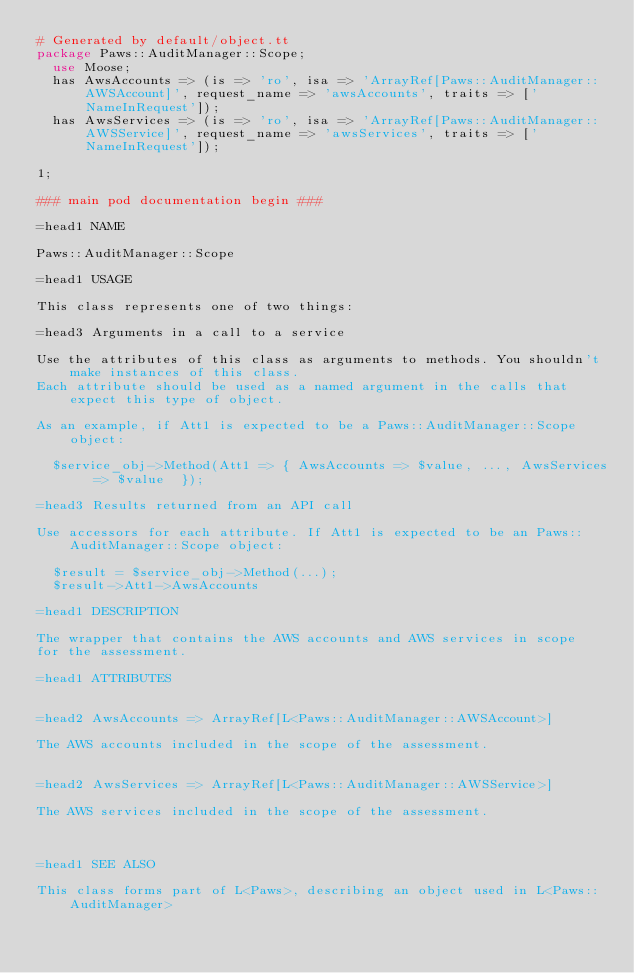<code> <loc_0><loc_0><loc_500><loc_500><_Perl_># Generated by default/object.tt
package Paws::AuditManager::Scope;
  use Moose;
  has AwsAccounts => (is => 'ro', isa => 'ArrayRef[Paws::AuditManager::AWSAccount]', request_name => 'awsAccounts', traits => ['NameInRequest']);
  has AwsServices => (is => 'ro', isa => 'ArrayRef[Paws::AuditManager::AWSService]', request_name => 'awsServices', traits => ['NameInRequest']);

1;

### main pod documentation begin ###

=head1 NAME

Paws::AuditManager::Scope

=head1 USAGE

This class represents one of two things:

=head3 Arguments in a call to a service

Use the attributes of this class as arguments to methods. You shouldn't make instances of this class. 
Each attribute should be used as a named argument in the calls that expect this type of object.

As an example, if Att1 is expected to be a Paws::AuditManager::Scope object:

  $service_obj->Method(Att1 => { AwsAccounts => $value, ..., AwsServices => $value  });

=head3 Results returned from an API call

Use accessors for each attribute. If Att1 is expected to be an Paws::AuditManager::Scope object:

  $result = $service_obj->Method(...);
  $result->Att1->AwsAccounts

=head1 DESCRIPTION

The wrapper that contains the AWS accounts and AWS services in scope
for the assessment.

=head1 ATTRIBUTES


=head2 AwsAccounts => ArrayRef[L<Paws::AuditManager::AWSAccount>]

The AWS accounts included in the scope of the assessment.


=head2 AwsServices => ArrayRef[L<Paws::AuditManager::AWSService>]

The AWS services included in the scope of the assessment.



=head1 SEE ALSO

This class forms part of L<Paws>, describing an object used in L<Paws::AuditManager>
</code> 